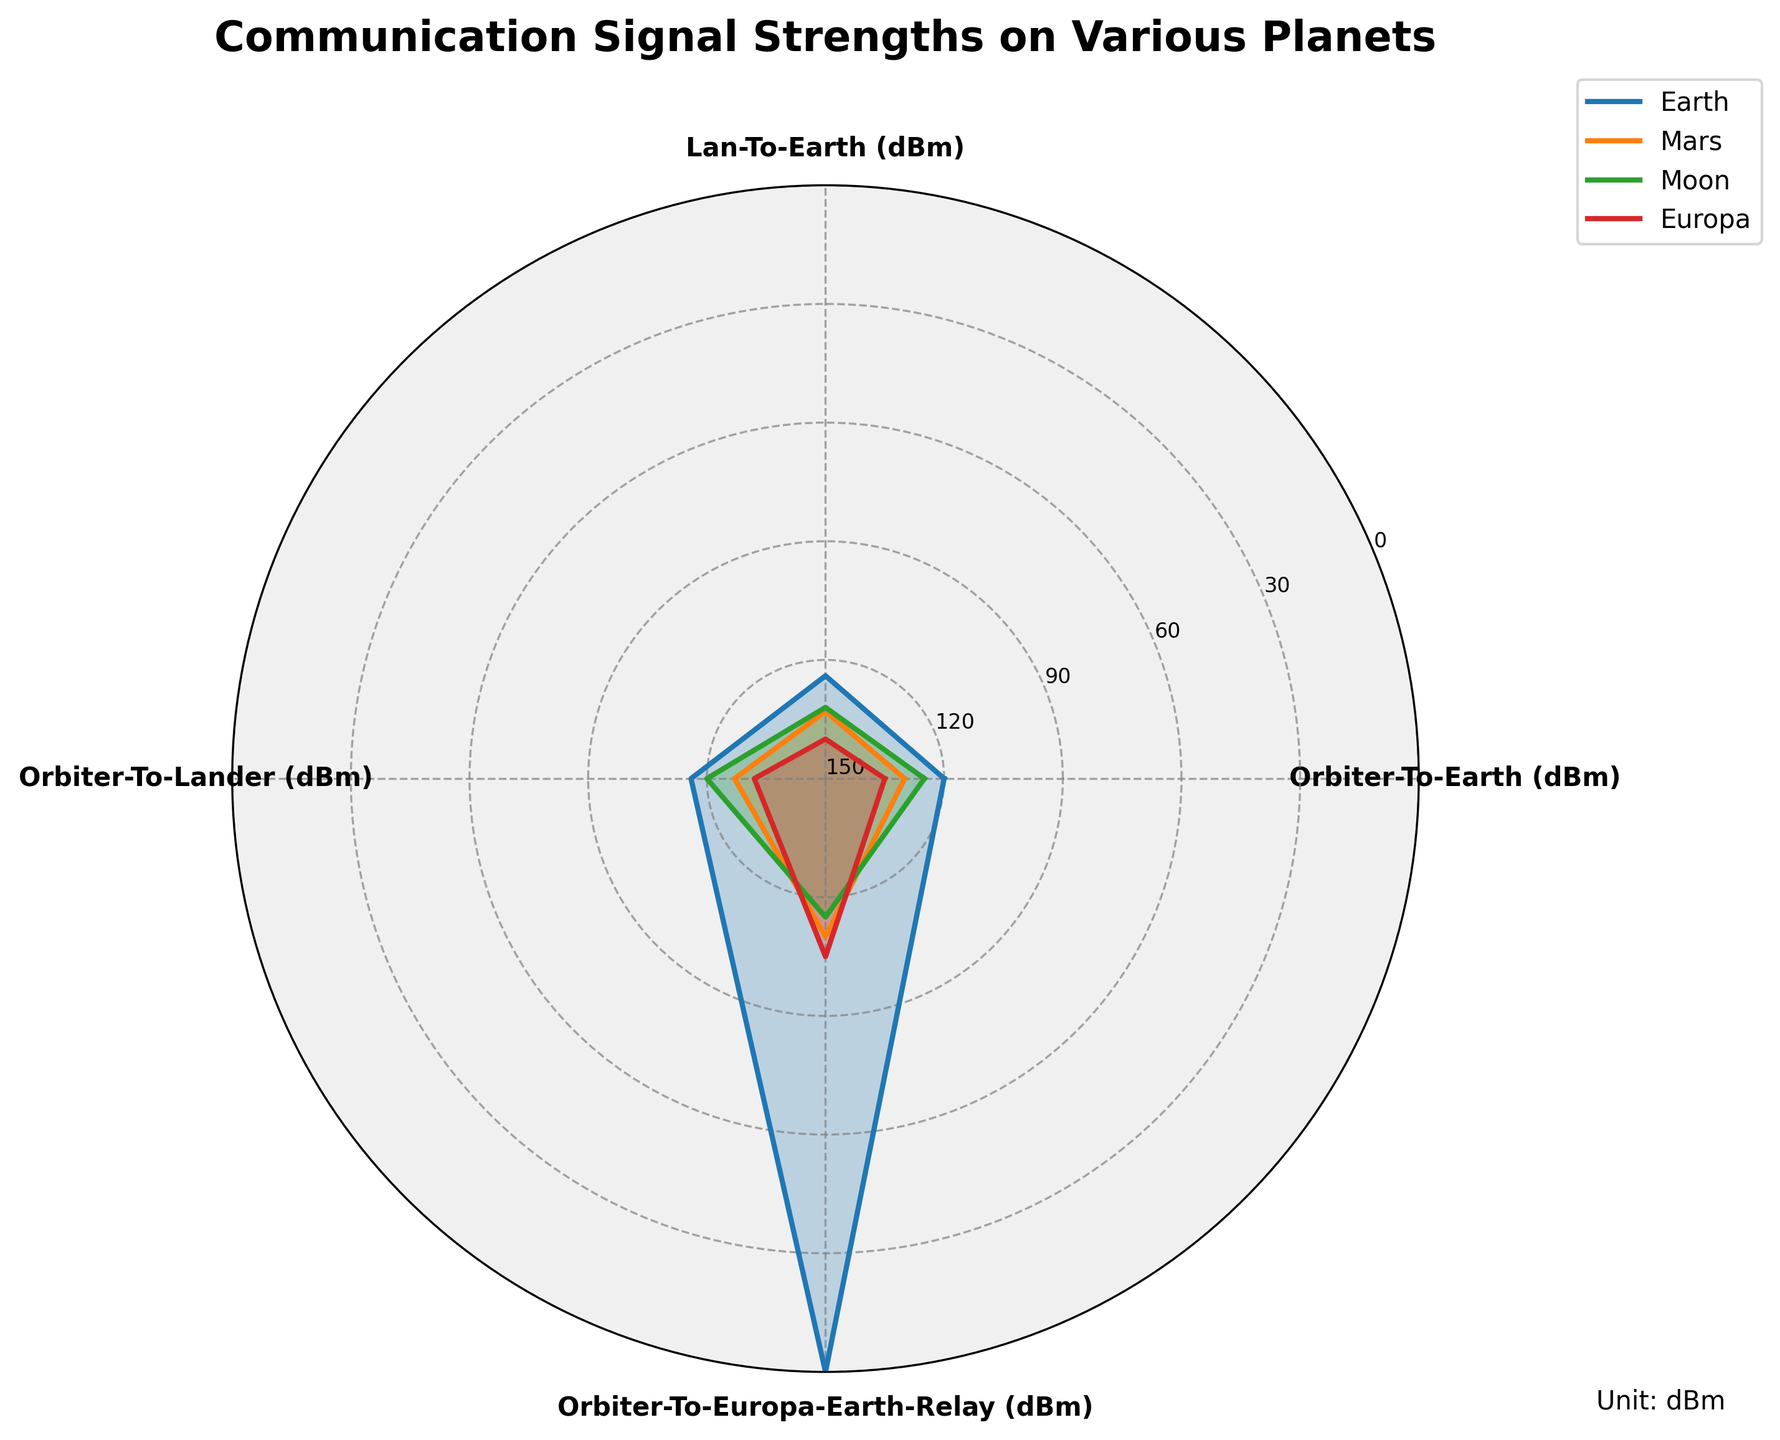What is the title of the figure? The title is typically at the top of the figure, indicating what the chart is about.
Answer: Communication Signal Strengths on Various Planets What is the weakest signal strength for Moon in the chart? Look for the lowest position of the Moon's radar plot line. It's at the Orbiter-To-Earth Relay category, which appears around -132 dBm.
Answer: -132 dBm Which planet has the strongest Orbiter-To-Earth signal? Compare the Orbiter-To-Earth values for all planets. The highest value, closest to zero, is for Earth at -120 dBm.
Answer: Earth How does the signal strength of Mars Orbiter-To-Lan compare to Moon Orbiter-To-Lan? Find the respective values for Mars and Moon in the Orbiter-To-Lan category. Mars is at -133 dBm and Moon is at -132 dBm. Moon's signal is stronger by 1 dBm.
Answer: Moon is stronger by 1 dBm What is the average signal strength of Earth across all categories? Summing the values: -120 + -124 + -116 + 0 = -360. Then, divide by the number of categories (4). The calculation gives -360 / 4 = -90 dBm.
Answer: -90 dBm Which category shows the smallest range of signal strengths across all planets? Compare the range (difference between max and min values) for each category. Orbiter-To-Earth has the smallest range: (Max: -120 for Earth, Min: -135 for Europa), which is 15 dBm.
Answer: Orbiter-To-Earth Rank the planets based on their Orbiter-To-Europa-Earth-Relay signals from best to worst. Compare the Orbiter-To-Europa-Earth-Relay values for all planets: Earth (0 dBm), Europa (-105 dBm), Moon (-115 dBm), Mars (-110 dBm). So, the ranking is Earth > Europa > Mars > Moon.
Answer: Earth > Europa > Mars > Moon Which planet has the most consistent signal strengths across all categories? Calculate the standard deviations of the signal values for each planet. The planet with the smallest standard deviation is the most consistent.
Answer: Earth 